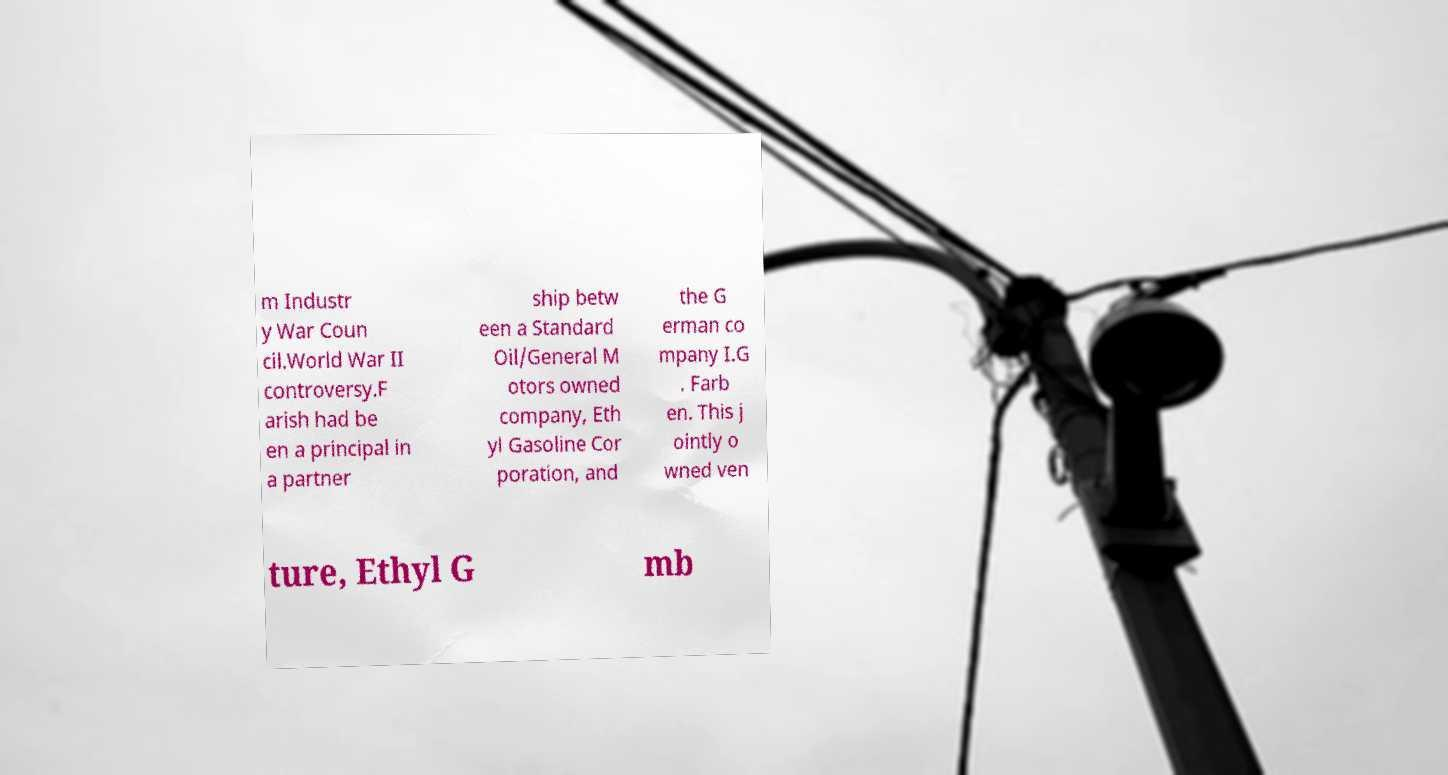Please identify and transcribe the text found in this image. m Industr y War Coun cil.World War II controversy.F arish had be en a principal in a partner ship betw een a Standard Oil/General M otors owned company, Eth yl Gasoline Cor poration, and the G erman co mpany I.G . Farb en. This j ointly o wned ven ture, Ethyl G mb 